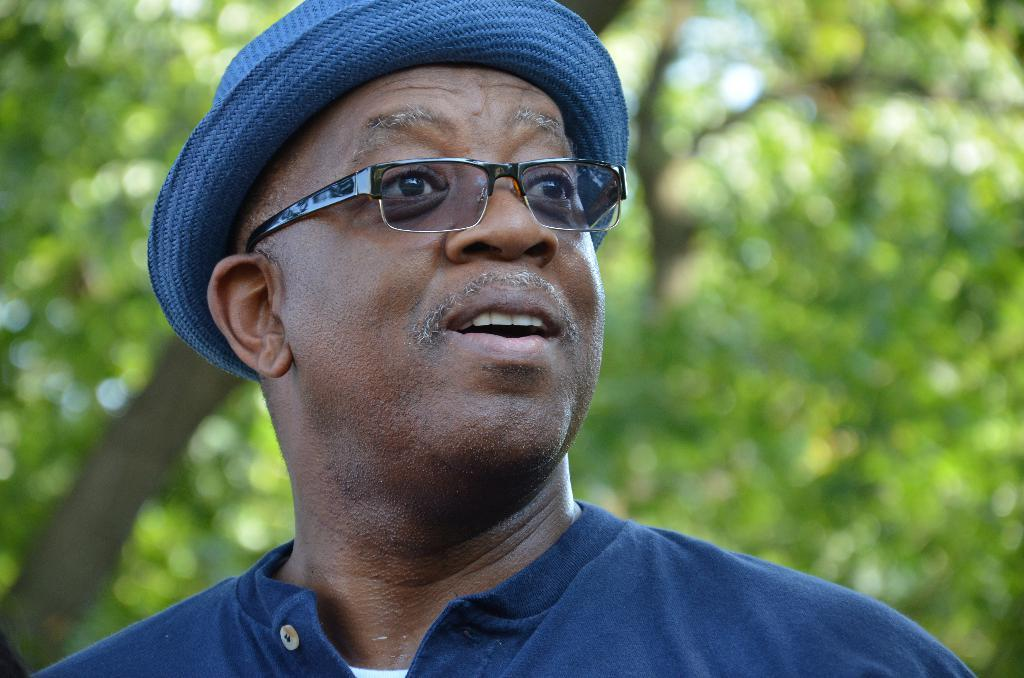What is the person in the image wearing? The person is wearing a blue and white color dress, a hat, and glasses. Can you describe the person's attire in more detail? The dress is blue and white, and the person is also wearing a hat and glasses. What can be seen in the background of the image? There are trees visible in the background of the image. What type of boat is visible in the scene? There is no boat present in the image; it features a person wearing a blue and white color dress, a hat, and glasses, with trees visible in the background. 